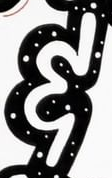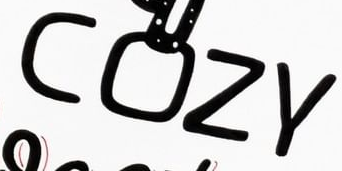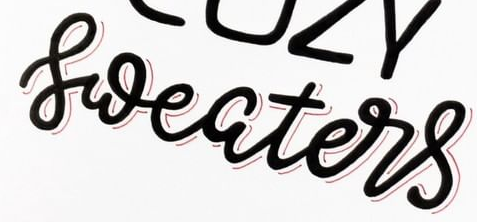Read the text from these images in sequence, separated by a semicolon. &; COZY; sweaters 